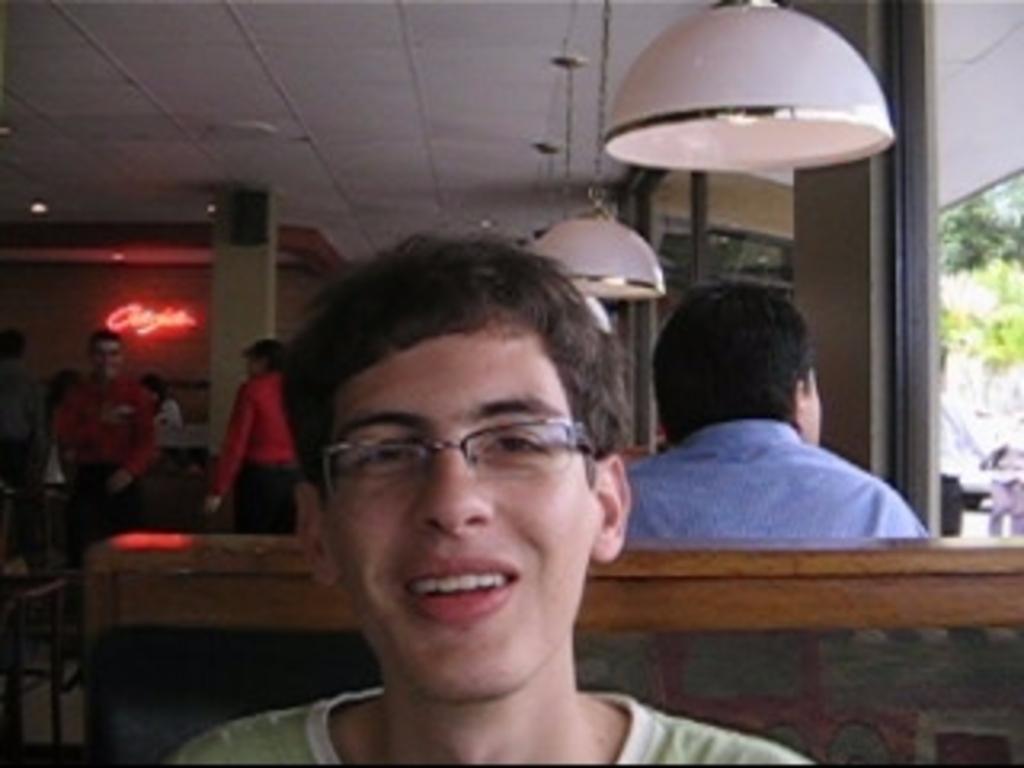How would you summarize this image in a sentence or two? In this picture there is a man sitting in the sofa. He is wearing green color T shirt and spectacles. In the background there are some people standing. I can observe some lights hanged to the ceiling. On the right side there is a glass. In the background I can observe some trees. 